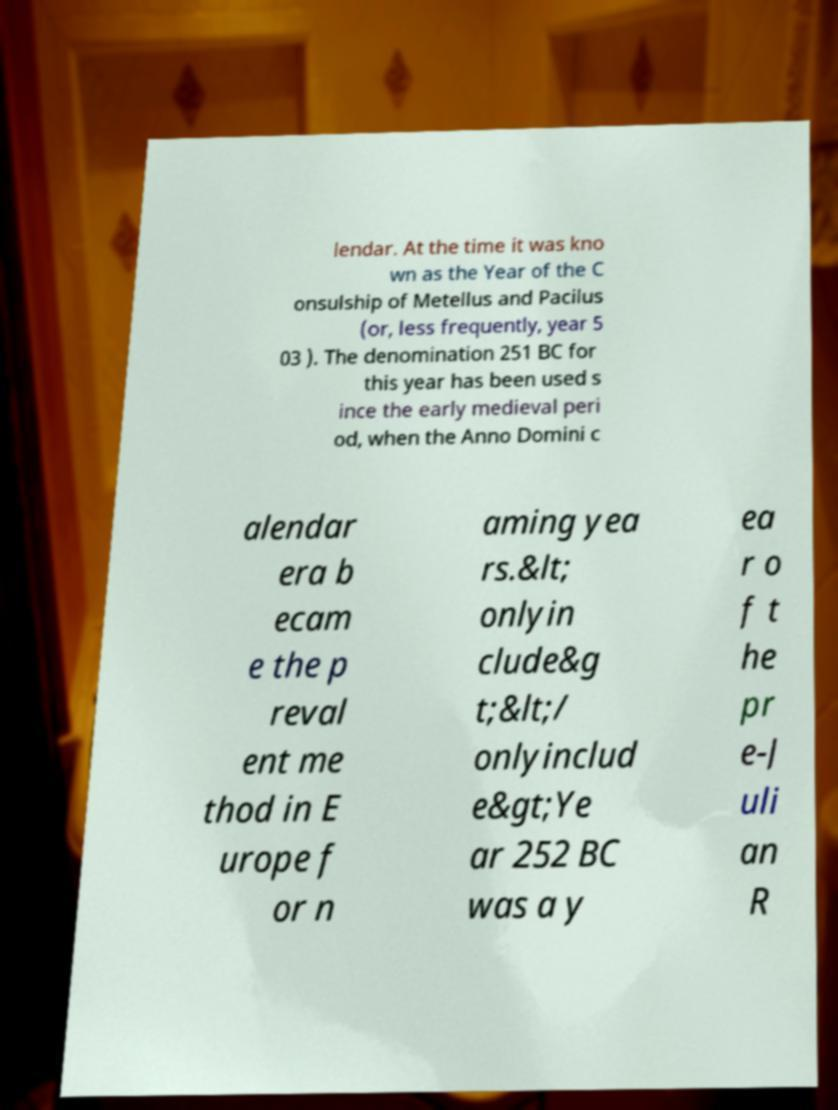Could you extract and type out the text from this image? lendar. At the time it was kno wn as the Year of the C onsulship of Metellus and Pacilus (or, less frequently, year 5 03 ). The denomination 251 BC for this year has been used s ince the early medieval peri od, when the Anno Domini c alendar era b ecam e the p reval ent me thod in E urope f or n aming yea rs.&lt; onlyin clude&g t;&lt;/ onlyinclud e&gt;Ye ar 252 BC was a y ea r o f t he pr e-J uli an R 